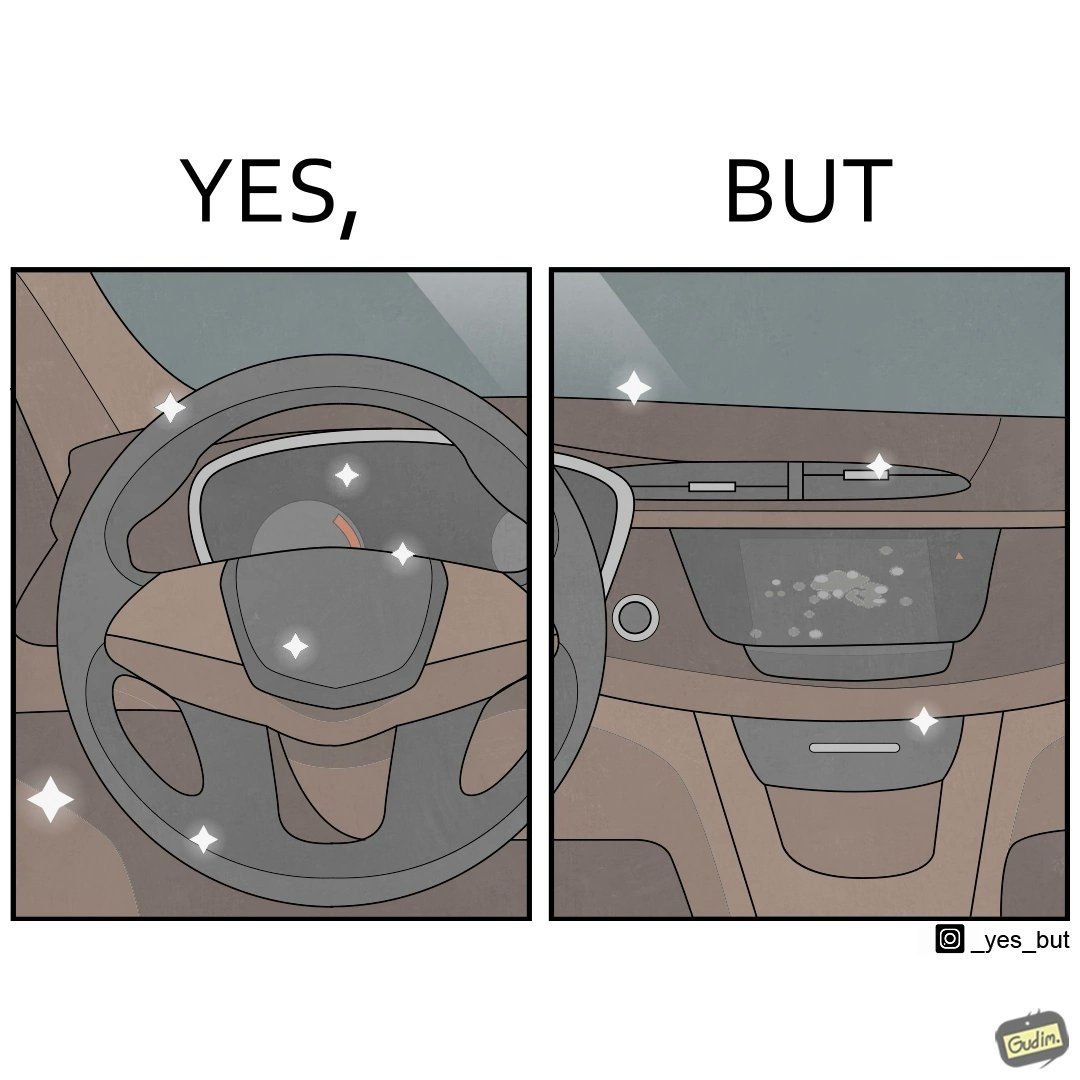Is this image satirical or non-satirical? Yes, this image is satirical. 